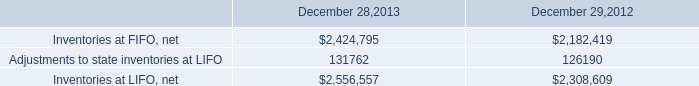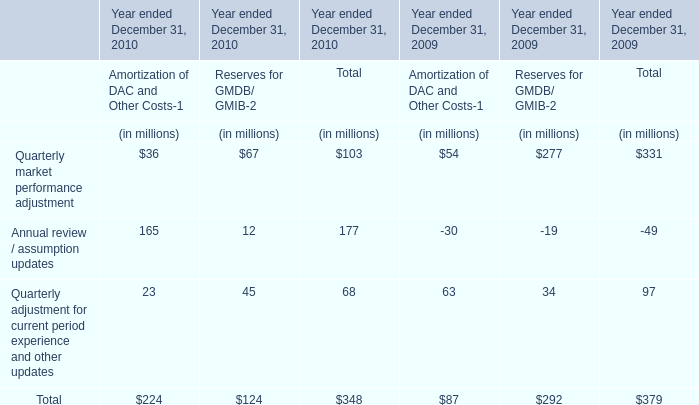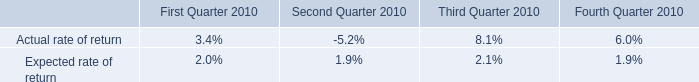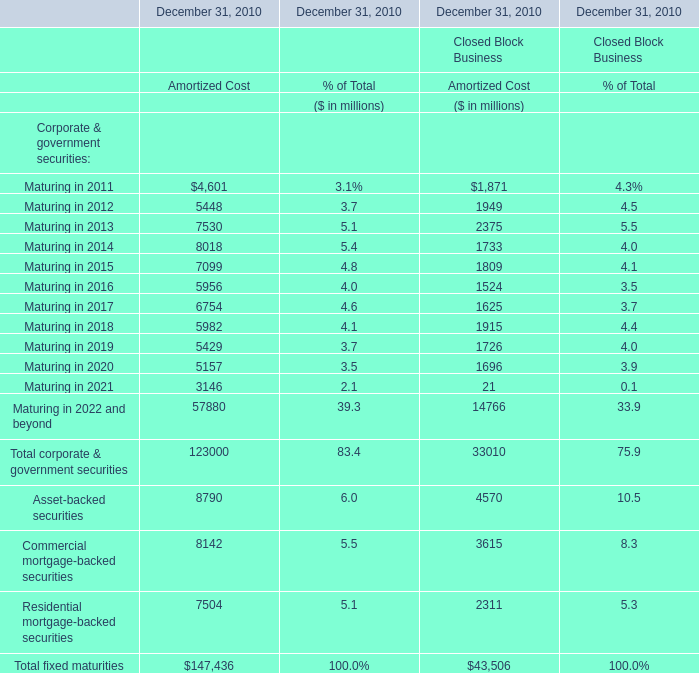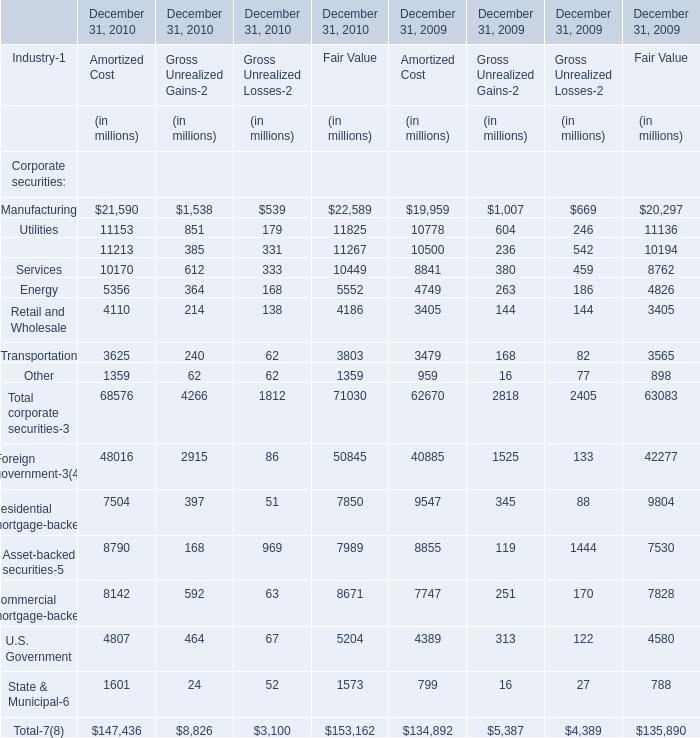Does the value of Manufacturing for Gross Unrealized Gains-2 in 2010 greater than that in 2009? 
Answer: No. 